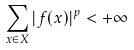<formula> <loc_0><loc_0><loc_500><loc_500>\sum _ { x \in X } | f ( x ) | ^ { p } < + \infty</formula> 